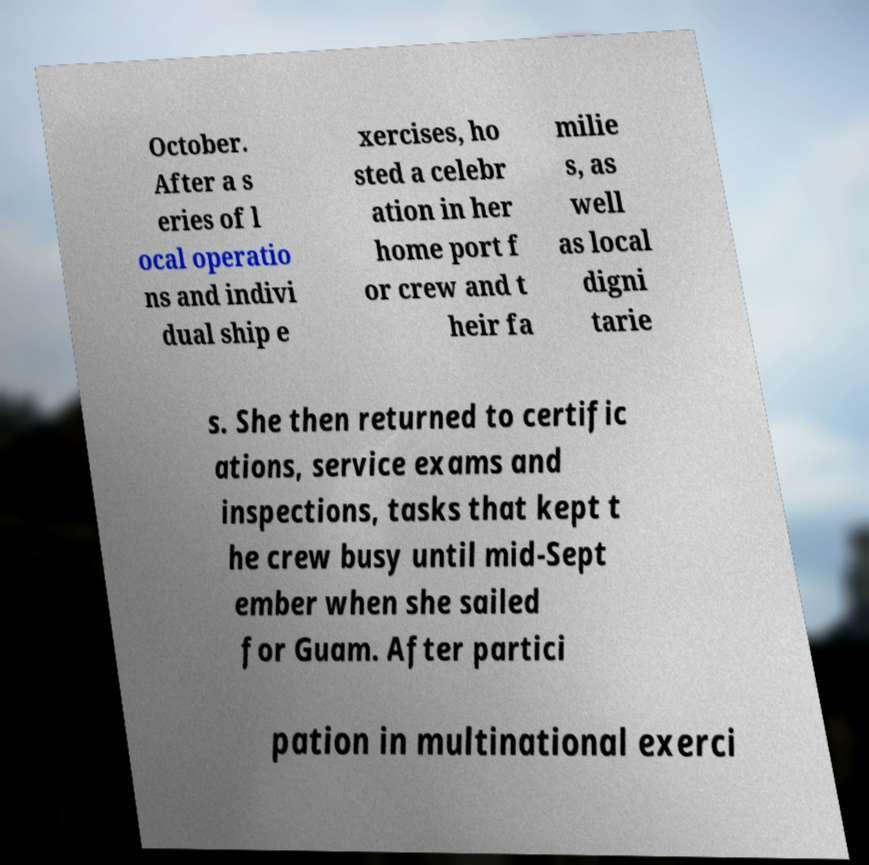There's text embedded in this image that I need extracted. Can you transcribe it verbatim? October. After a s eries of l ocal operatio ns and indivi dual ship e xercises, ho sted a celebr ation in her home port f or crew and t heir fa milie s, as well as local digni tarie s. She then returned to certific ations, service exams and inspections, tasks that kept t he crew busy until mid-Sept ember when she sailed for Guam. After partici pation in multinational exerci 